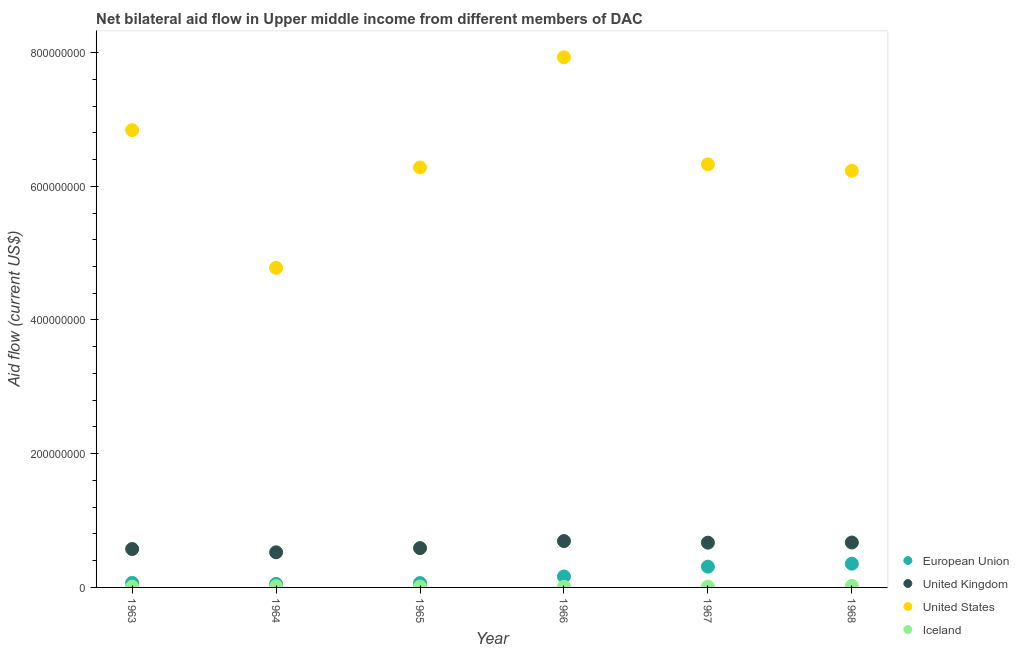How many different coloured dotlines are there?
Make the answer very short. 4. What is the amount of aid given by us in 1968?
Offer a terse response. 6.23e+08. Across all years, what is the maximum amount of aid given by eu?
Offer a very short reply. 3.55e+07. Across all years, what is the minimum amount of aid given by eu?
Ensure brevity in your answer.  5.22e+06. In which year was the amount of aid given by eu maximum?
Keep it short and to the point. 1968. In which year was the amount of aid given by eu minimum?
Keep it short and to the point. 1964. What is the total amount of aid given by iceland in the graph?
Keep it short and to the point. 8.60e+06. What is the difference between the amount of aid given by iceland in 1966 and that in 1967?
Give a very brief answer. -1.90e+05. What is the difference between the amount of aid given by eu in 1963 and the amount of aid given by uk in 1967?
Ensure brevity in your answer.  -6.02e+07. What is the average amount of aid given by eu per year?
Provide a short and direct response. 1.69e+07. In the year 1964, what is the difference between the amount of aid given by eu and amount of aid given by uk?
Keep it short and to the point. -4.73e+07. In how many years, is the amount of aid given by us greater than 760000000 US$?
Your response must be concise. 1. What is the ratio of the amount of aid given by eu in 1964 to that in 1967?
Give a very brief answer. 0.17. Is the difference between the amount of aid given by us in 1963 and 1965 greater than the difference between the amount of aid given by uk in 1963 and 1965?
Provide a short and direct response. Yes. What is the difference between the highest and the second highest amount of aid given by iceland?
Give a very brief answer. 5.10e+05. What is the difference between the highest and the lowest amount of aid given by eu?
Keep it short and to the point. 3.03e+07. Is the amount of aid given by iceland strictly greater than the amount of aid given by eu over the years?
Offer a very short reply. No. Is the amount of aid given by us strictly less than the amount of aid given by eu over the years?
Give a very brief answer. No. How many dotlines are there?
Your response must be concise. 4. How many years are there in the graph?
Offer a very short reply. 6. What is the difference between two consecutive major ticks on the Y-axis?
Provide a short and direct response. 2.00e+08. Are the values on the major ticks of Y-axis written in scientific E-notation?
Your answer should be very brief. No. Does the graph contain any zero values?
Make the answer very short. No. Where does the legend appear in the graph?
Ensure brevity in your answer.  Bottom right. How are the legend labels stacked?
Your answer should be very brief. Vertical. What is the title of the graph?
Your response must be concise. Net bilateral aid flow in Upper middle income from different members of DAC. What is the label or title of the X-axis?
Your response must be concise. Year. What is the label or title of the Y-axis?
Offer a very short reply. Aid flow (current US$). What is the Aid flow (current US$) in European Union in 1963?
Ensure brevity in your answer.  6.73e+06. What is the Aid flow (current US$) of United Kingdom in 1963?
Your answer should be compact. 5.74e+07. What is the Aid flow (current US$) of United States in 1963?
Your response must be concise. 6.84e+08. What is the Aid flow (current US$) in Iceland in 1963?
Provide a succinct answer. 1.18e+06. What is the Aid flow (current US$) in European Union in 1964?
Give a very brief answer. 5.22e+06. What is the Aid flow (current US$) of United Kingdom in 1964?
Your answer should be compact. 5.25e+07. What is the Aid flow (current US$) of United States in 1964?
Ensure brevity in your answer.  4.78e+08. What is the Aid flow (current US$) of Iceland in 1964?
Ensure brevity in your answer.  1.74e+06. What is the Aid flow (current US$) in European Union in 1965?
Make the answer very short. 6.46e+06. What is the Aid flow (current US$) in United Kingdom in 1965?
Offer a terse response. 5.88e+07. What is the Aid flow (current US$) in United States in 1965?
Ensure brevity in your answer.  6.28e+08. What is the Aid flow (current US$) in Iceland in 1965?
Provide a succinct answer. 1.26e+06. What is the Aid flow (current US$) of European Union in 1966?
Give a very brief answer. 1.64e+07. What is the Aid flow (current US$) in United Kingdom in 1966?
Provide a succinct answer. 6.93e+07. What is the Aid flow (current US$) in United States in 1966?
Provide a succinct answer. 7.93e+08. What is the Aid flow (current US$) in Iceland in 1966?
Offer a very short reply. 9.90e+05. What is the Aid flow (current US$) of European Union in 1967?
Your answer should be compact. 3.11e+07. What is the Aid flow (current US$) of United Kingdom in 1967?
Ensure brevity in your answer.  6.69e+07. What is the Aid flow (current US$) of United States in 1967?
Give a very brief answer. 6.33e+08. What is the Aid flow (current US$) of Iceland in 1967?
Your response must be concise. 1.18e+06. What is the Aid flow (current US$) of European Union in 1968?
Your response must be concise. 3.55e+07. What is the Aid flow (current US$) of United Kingdom in 1968?
Keep it short and to the point. 6.72e+07. What is the Aid flow (current US$) in United States in 1968?
Your answer should be compact. 6.23e+08. What is the Aid flow (current US$) of Iceland in 1968?
Offer a terse response. 2.25e+06. Across all years, what is the maximum Aid flow (current US$) of European Union?
Your answer should be very brief. 3.55e+07. Across all years, what is the maximum Aid flow (current US$) of United Kingdom?
Offer a very short reply. 6.93e+07. Across all years, what is the maximum Aid flow (current US$) in United States?
Make the answer very short. 7.93e+08. Across all years, what is the maximum Aid flow (current US$) of Iceland?
Make the answer very short. 2.25e+06. Across all years, what is the minimum Aid flow (current US$) in European Union?
Your answer should be compact. 5.22e+06. Across all years, what is the minimum Aid flow (current US$) of United Kingdom?
Provide a short and direct response. 5.25e+07. Across all years, what is the minimum Aid flow (current US$) in United States?
Provide a succinct answer. 4.78e+08. Across all years, what is the minimum Aid flow (current US$) of Iceland?
Make the answer very short. 9.90e+05. What is the total Aid flow (current US$) in European Union in the graph?
Your answer should be compact. 1.01e+08. What is the total Aid flow (current US$) in United Kingdom in the graph?
Provide a short and direct response. 3.72e+08. What is the total Aid flow (current US$) of United States in the graph?
Provide a succinct answer. 3.84e+09. What is the total Aid flow (current US$) of Iceland in the graph?
Your answer should be very brief. 8.60e+06. What is the difference between the Aid flow (current US$) in European Union in 1963 and that in 1964?
Give a very brief answer. 1.51e+06. What is the difference between the Aid flow (current US$) of United Kingdom in 1963 and that in 1964?
Make the answer very short. 4.92e+06. What is the difference between the Aid flow (current US$) in United States in 1963 and that in 1964?
Keep it short and to the point. 2.06e+08. What is the difference between the Aid flow (current US$) of Iceland in 1963 and that in 1964?
Your response must be concise. -5.60e+05. What is the difference between the Aid flow (current US$) in European Union in 1963 and that in 1965?
Provide a succinct answer. 2.70e+05. What is the difference between the Aid flow (current US$) of United Kingdom in 1963 and that in 1965?
Keep it short and to the point. -1.36e+06. What is the difference between the Aid flow (current US$) of United States in 1963 and that in 1965?
Your answer should be very brief. 5.59e+07. What is the difference between the Aid flow (current US$) of European Union in 1963 and that in 1966?
Your answer should be compact. -9.64e+06. What is the difference between the Aid flow (current US$) in United Kingdom in 1963 and that in 1966?
Keep it short and to the point. -1.19e+07. What is the difference between the Aid flow (current US$) of United States in 1963 and that in 1966?
Provide a short and direct response. -1.09e+08. What is the difference between the Aid flow (current US$) in European Union in 1963 and that in 1967?
Offer a terse response. -2.44e+07. What is the difference between the Aid flow (current US$) of United Kingdom in 1963 and that in 1967?
Keep it short and to the point. -9.49e+06. What is the difference between the Aid flow (current US$) in United States in 1963 and that in 1967?
Offer a terse response. 5.12e+07. What is the difference between the Aid flow (current US$) in European Union in 1963 and that in 1968?
Provide a short and direct response. -2.88e+07. What is the difference between the Aid flow (current US$) in United Kingdom in 1963 and that in 1968?
Offer a terse response. -9.73e+06. What is the difference between the Aid flow (current US$) in United States in 1963 and that in 1968?
Your answer should be very brief. 6.08e+07. What is the difference between the Aid flow (current US$) of Iceland in 1963 and that in 1968?
Your answer should be compact. -1.07e+06. What is the difference between the Aid flow (current US$) of European Union in 1964 and that in 1965?
Offer a terse response. -1.24e+06. What is the difference between the Aid flow (current US$) of United Kingdom in 1964 and that in 1965?
Keep it short and to the point. -6.28e+06. What is the difference between the Aid flow (current US$) in United States in 1964 and that in 1965?
Provide a succinct answer. -1.50e+08. What is the difference between the Aid flow (current US$) of European Union in 1964 and that in 1966?
Keep it short and to the point. -1.12e+07. What is the difference between the Aid flow (current US$) in United Kingdom in 1964 and that in 1966?
Offer a very short reply. -1.68e+07. What is the difference between the Aid flow (current US$) of United States in 1964 and that in 1966?
Your answer should be very brief. -3.15e+08. What is the difference between the Aid flow (current US$) of Iceland in 1964 and that in 1966?
Offer a terse response. 7.50e+05. What is the difference between the Aid flow (current US$) of European Union in 1964 and that in 1967?
Your response must be concise. -2.59e+07. What is the difference between the Aid flow (current US$) of United Kingdom in 1964 and that in 1967?
Keep it short and to the point. -1.44e+07. What is the difference between the Aid flow (current US$) in United States in 1964 and that in 1967?
Give a very brief answer. -1.55e+08. What is the difference between the Aid flow (current US$) of Iceland in 1964 and that in 1967?
Offer a terse response. 5.60e+05. What is the difference between the Aid flow (current US$) of European Union in 1964 and that in 1968?
Your response must be concise. -3.03e+07. What is the difference between the Aid flow (current US$) of United Kingdom in 1964 and that in 1968?
Your answer should be compact. -1.46e+07. What is the difference between the Aid flow (current US$) of United States in 1964 and that in 1968?
Provide a short and direct response. -1.45e+08. What is the difference between the Aid flow (current US$) in Iceland in 1964 and that in 1968?
Make the answer very short. -5.10e+05. What is the difference between the Aid flow (current US$) of European Union in 1965 and that in 1966?
Offer a terse response. -9.91e+06. What is the difference between the Aid flow (current US$) of United Kingdom in 1965 and that in 1966?
Your answer should be compact. -1.05e+07. What is the difference between the Aid flow (current US$) in United States in 1965 and that in 1966?
Make the answer very short. -1.65e+08. What is the difference between the Aid flow (current US$) in European Union in 1965 and that in 1967?
Give a very brief answer. -2.46e+07. What is the difference between the Aid flow (current US$) of United Kingdom in 1965 and that in 1967?
Your response must be concise. -8.13e+06. What is the difference between the Aid flow (current US$) of United States in 1965 and that in 1967?
Keep it short and to the point. -4.62e+06. What is the difference between the Aid flow (current US$) in Iceland in 1965 and that in 1967?
Make the answer very short. 8.00e+04. What is the difference between the Aid flow (current US$) in European Union in 1965 and that in 1968?
Your response must be concise. -2.90e+07. What is the difference between the Aid flow (current US$) of United Kingdom in 1965 and that in 1968?
Your answer should be very brief. -8.37e+06. What is the difference between the Aid flow (current US$) of United States in 1965 and that in 1968?
Make the answer very short. 4.89e+06. What is the difference between the Aid flow (current US$) in Iceland in 1965 and that in 1968?
Offer a very short reply. -9.90e+05. What is the difference between the Aid flow (current US$) of European Union in 1966 and that in 1967?
Give a very brief answer. -1.47e+07. What is the difference between the Aid flow (current US$) of United Kingdom in 1966 and that in 1967?
Provide a short and direct response. 2.40e+06. What is the difference between the Aid flow (current US$) in United States in 1966 and that in 1967?
Give a very brief answer. 1.60e+08. What is the difference between the Aid flow (current US$) of European Union in 1966 and that in 1968?
Offer a terse response. -1.91e+07. What is the difference between the Aid flow (current US$) of United Kingdom in 1966 and that in 1968?
Provide a succinct answer. 2.16e+06. What is the difference between the Aid flow (current US$) of United States in 1966 and that in 1968?
Your response must be concise. 1.70e+08. What is the difference between the Aid flow (current US$) of Iceland in 1966 and that in 1968?
Your answer should be compact. -1.26e+06. What is the difference between the Aid flow (current US$) in European Union in 1967 and that in 1968?
Keep it short and to the point. -4.41e+06. What is the difference between the Aid flow (current US$) in United Kingdom in 1967 and that in 1968?
Ensure brevity in your answer.  -2.40e+05. What is the difference between the Aid flow (current US$) in United States in 1967 and that in 1968?
Offer a very short reply. 9.51e+06. What is the difference between the Aid flow (current US$) in Iceland in 1967 and that in 1968?
Offer a very short reply. -1.07e+06. What is the difference between the Aid flow (current US$) of European Union in 1963 and the Aid flow (current US$) of United Kingdom in 1964?
Your response must be concise. -4.58e+07. What is the difference between the Aid flow (current US$) in European Union in 1963 and the Aid flow (current US$) in United States in 1964?
Offer a terse response. -4.71e+08. What is the difference between the Aid flow (current US$) in European Union in 1963 and the Aid flow (current US$) in Iceland in 1964?
Offer a terse response. 4.99e+06. What is the difference between the Aid flow (current US$) of United Kingdom in 1963 and the Aid flow (current US$) of United States in 1964?
Provide a succinct answer. -4.21e+08. What is the difference between the Aid flow (current US$) of United Kingdom in 1963 and the Aid flow (current US$) of Iceland in 1964?
Give a very brief answer. 5.57e+07. What is the difference between the Aid flow (current US$) of United States in 1963 and the Aid flow (current US$) of Iceland in 1964?
Provide a succinct answer. 6.82e+08. What is the difference between the Aid flow (current US$) in European Union in 1963 and the Aid flow (current US$) in United Kingdom in 1965?
Provide a succinct answer. -5.21e+07. What is the difference between the Aid flow (current US$) of European Union in 1963 and the Aid flow (current US$) of United States in 1965?
Your response must be concise. -6.21e+08. What is the difference between the Aid flow (current US$) of European Union in 1963 and the Aid flow (current US$) of Iceland in 1965?
Offer a terse response. 5.47e+06. What is the difference between the Aid flow (current US$) in United Kingdom in 1963 and the Aid flow (current US$) in United States in 1965?
Make the answer very short. -5.71e+08. What is the difference between the Aid flow (current US$) in United Kingdom in 1963 and the Aid flow (current US$) in Iceland in 1965?
Offer a very short reply. 5.62e+07. What is the difference between the Aid flow (current US$) in United States in 1963 and the Aid flow (current US$) in Iceland in 1965?
Your answer should be very brief. 6.83e+08. What is the difference between the Aid flow (current US$) in European Union in 1963 and the Aid flow (current US$) in United Kingdom in 1966?
Make the answer very short. -6.26e+07. What is the difference between the Aid flow (current US$) in European Union in 1963 and the Aid flow (current US$) in United States in 1966?
Provide a short and direct response. -7.86e+08. What is the difference between the Aid flow (current US$) of European Union in 1963 and the Aid flow (current US$) of Iceland in 1966?
Provide a succinct answer. 5.74e+06. What is the difference between the Aid flow (current US$) of United Kingdom in 1963 and the Aid flow (current US$) of United States in 1966?
Give a very brief answer. -7.35e+08. What is the difference between the Aid flow (current US$) of United Kingdom in 1963 and the Aid flow (current US$) of Iceland in 1966?
Keep it short and to the point. 5.65e+07. What is the difference between the Aid flow (current US$) of United States in 1963 and the Aid flow (current US$) of Iceland in 1966?
Keep it short and to the point. 6.83e+08. What is the difference between the Aid flow (current US$) of European Union in 1963 and the Aid flow (current US$) of United Kingdom in 1967?
Your response must be concise. -6.02e+07. What is the difference between the Aid flow (current US$) in European Union in 1963 and the Aid flow (current US$) in United States in 1967?
Offer a terse response. -6.26e+08. What is the difference between the Aid flow (current US$) in European Union in 1963 and the Aid flow (current US$) in Iceland in 1967?
Offer a terse response. 5.55e+06. What is the difference between the Aid flow (current US$) in United Kingdom in 1963 and the Aid flow (current US$) in United States in 1967?
Offer a terse response. -5.75e+08. What is the difference between the Aid flow (current US$) of United Kingdom in 1963 and the Aid flow (current US$) of Iceland in 1967?
Make the answer very short. 5.63e+07. What is the difference between the Aid flow (current US$) of United States in 1963 and the Aid flow (current US$) of Iceland in 1967?
Keep it short and to the point. 6.83e+08. What is the difference between the Aid flow (current US$) of European Union in 1963 and the Aid flow (current US$) of United Kingdom in 1968?
Your answer should be very brief. -6.04e+07. What is the difference between the Aid flow (current US$) of European Union in 1963 and the Aid flow (current US$) of United States in 1968?
Offer a terse response. -6.17e+08. What is the difference between the Aid flow (current US$) in European Union in 1963 and the Aid flow (current US$) in Iceland in 1968?
Ensure brevity in your answer.  4.48e+06. What is the difference between the Aid flow (current US$) in United Kingdom in 1963 and the Aid flow (current US$) in United States in 1968?
Make the answer very short. -5.66e+08. What is the difference between the Aid flow (current US$) in United Kingdom in 1963 and the Aid flow (current US$) in Iceland in 1968?
Give a very brief answer. 5.52e+07. What is the difference between the Aid flow (current US$) in United States in 1963 and the Aid flow (current US$) in Iceland in 1968?
Your answer should be very brief. 6.82e+08. What is the difference between the Aid flow (current US$) in European Union in 1964 and the Aid flow (current US$) in United Kingdom in 1965?
Your response must be concise. -5.36e+07. What is the difference between the Aid flow (current US$) of European Union in 1964 and the Aid flow (current US$) of United States in 1965?
Your answer should be compact. -6.23e+08. What is the difference between the Aid flow (current US$) in European Union in 1964 and the Aid flow (current US$) in Iceland in 1965?
Your answer should be compact. 3.96e+06. What is the difference between the Aid flow (current US$) of United Kingdom in 1964 and the Aid flow (current US$) of United States in 1965?
Provide a succinct answer. -5.76e+08. What is the difference between the Aid flow (current US$) in United Kingdom in 1964 and the Aid flow (current US$) in Iceland in 1965?
Your response must be concise. 5.13e+07. What is the difference between the Aid flow (current US$) in United States in 1964 and the Aid flow (current US$) in Iceland in 1965?
Give a very brief answer. 4.77e+08. What is the difference between the Aid flow (current US$) of European Union in 1964 and the Aid flow (current US$) of United Kingdom in 1966?
Your response must be concise. -6.41e+07. What is the difference between the Aid flow (current US$) in European Union in 1964 and the Aid flow (current US$) in United States in 1966?
Offer a very short reply. -7.88e+08. What is the difference between the Aid flow (current US$) of European Union in 1964 and the Aid flow (current US$) of Iceland in 1966?
Provide a short and direct response. 4.23e+06. What is the difference between the Aid flow (current US$) of United Kingdom in 1964 and the Aid flow (current US$) of United States in 1966?
Make the answer very short. -7.40e+08. What is the difference between the Aid flow (current US$) of United Kingdom in 1964 and the Aid flow (current US$) of Iceland in 1966?
Make the answer very short. 5.15e+07. What is the difference between the Aid flow (current US$) of United States in 1964 and the Aid flow (current US$) of Iceland in 1966?
Provide a short and direct response. 4.77e+08. What is the difference between the Aid flow (current US$) of European Union in 1964 and the Aid flow (current US$) of United Kingdom in 1967?
Provide a short and direct response. -6.17e+07. What is the difference between the Aid flow (current US$) of European Union in 1964 and the Aid flow (current US$) of United States in 1967?
Offer a terse response. -6.28e+08. What is the difference between the Aid flow (current US$) in European Union in 1964 and the Aid flow (current US$) in Iceland in 1967?
Your response must be concise. 4.04e+06. What is the difference between the Aid flow (current US$) of United Kingdom in 1964 and the Aid flow (current US$) of United States in 1967?
Make the answer very short. -5.80e+08. What is the difference between the Aid flow (current US$) in United Kingdom in 1964 and the Aid flow (current US$) in Iceland in 1967?
Provide a short and direct response. 5.14e+07. What is the difference between the Aid flow (current US$) in United States in 1964 and the Aid flow (current US$) in Iceland in 1967?
Your response must be concise. 4.77e+08. What is the difference between the Aid flow (current US$) of European Union in 1964 and the Aid flow (current US$) of United Kingdom in 1968?
Offer a very short reply. -6.20e+07. What is the difference between the Aid flow (current US$) in European Union in 1964 and the Aid flow (current US$) in United States in 1968?
Offer a very short reply. -6.18e+08. What is the difference between the Aid flow (current US$) of European Union in 1964 and the Aid flow (current US$) of Iceland in 1968?
Provide a short and direct response. 2.97e+06. What is the difference between the Aid flow (current US$) in United Kingdom in 1964 and the Aid flow (current US$) in United States in 1968?
Provide a short and direct response. -5.71e+08. What is the difference between the Aid flow (current US$) of United Kingdom in 1964 and the Aid flow (current US$) of Iceland in 1968?
Offer a very short reply. 5.03e+07. What is the difference between the Aid flow (current US$) in United States in 1964 and the Aid flow (current US$) in Iceland in 1968?
Your answer should be very brief. 4.76e+08. What is the difference between the Aid flow (current US$) in European Union in 1965 and the Aid flow (current US$) in United Kingdom in 1966?
Give a very brief answer. -6.29e+07. What is the difference between the Aid flow (current US$) in European Union in 1965 and the Aid flow (current US$) in United States in 1966?
Make the answer very short. -7.86e+08. What is the difference between the Aid flow (current US$) in European Union in 1965 and the Aid flow (current US$) in Iceland in 1966?
Give a very brief answer. 5.47e+06. What is the difference between the Aid flow (current US$) of United Kingdom in 1965 and the Aid flow (current US$) of United States in 1966?
Provide a succinct answer. -7.34e+08. What is the difference between the Aid flow (current US$) in United Kingdom in 1965 and the Aid flow (current US$) in Iceland in 1966?
Your answer should be compact. 5.78e+07. What is the difference between the Aid flow (current US$) of United States in 1965 and the Aid flow (current US$) of Iceland in 1966?
Provide a succinct answer. 6.27e+08. What is the difference between the Aid flow (current US$) in European Union in 1965 and the Aid flow (current US$) in United Kingdom in 1967?
Your answer should be very brief. -6.05e+07. What is the difference between the Aid flow (current US$) of European Union in 1965 and the Aid flow (current US$) of United States in 1967?
Provide a short and direct response. -6.26e+08. What is the difference between the Aid flow (current US$) of European Union in 1965 and the Aid flow (current US$) of Iceland in 1967?
Make the answer very short. 5.28e+06. What is the difference between the Aid flow (current US$) of United Kingdom in 1965 and the Aid flow (current US$) of United States in 1967?
Your answer should be very brief. -5.74e+08. What is the difference between the Aid flow (current US$) in United Kingdom in 1965 and the Aid flow (current US$) in Iceland in 1967?
Ensure brevity in your answer.  5.76e+07. What is the difference between the Aid flow (current US$) of United States in 1965 and the Aid flow (current US$) of Iceland in 1967?
Ensure brevity in your answer.  6.27e+08. What is the difference between the Aid flow (current US$) in European Union in 1965 and the Aid flow (current US$) in United Kingdom in 1968?
Ensure brevity in your answer.  -6.07e+07. What is the difference between the Aid flow (current US$) in European Union in 1965 and the Aid flow (current US$) in United States in 1968?
Provide a short and direct response. -6.17e+08. What is the difference between the Aid flow (current US$) in European Union in 1965 and the Aid flow (current US$) in Iceland in 1968?
Your answer should be very brief. 4.21e+06. What is the difference between the Aid flow (current US$) in United Kingdom in 1965 and the Aid flow (current US$) in United States in 1968?
Provide a succinct answer. -5.64e+08. What is the difference between the Aid flow (current US$) of United Kingdom in 1965 and the Aid flow (current US$) of Iceland in 1968?
Provide a succinct answer. 5.66e+07. What is the difference between the Aid flow (current US$) in United States in 1965 and the Aid flow (current US$) in Iceland in 1968?
Your response must be concise. 6.26e+08. What is the difference between the Aid flow (current US$) in European Union in 1966 and the Aid flow (current US$) in United Kingdom in 1967?
Offer a very short reply. -5.06e+07. What is the difference between the Aid flow (current US$) of European Union in 1966 and the Aid flow (current US$) of United States in 1967?
Your response must be concise. -6.16e+08. What is the difference between the Aid flow (current US$) of European Union in 1966 and the Aid flow (current US$) of Iceland in 1967?
Provide a short and direct response. 1.52e+07. What is the difference between the Aid flow (current US$) in United Kingdom in 1966 and the Aid flow (current US$) in United States in 1967?
Provide a short and direct response. -5.63e+08. What is the difference between the Aid flow (current US$) in United Kingdom in 1966 and the Aid flow (current US$) in Iceland in 1967?
Make the answer very short. 6.82e+07. What is the difference between the Aid flow (current US$) in United States in 1966 and the Aid flow (current US$) in Iceland in 1967?
Make the answer very short. 7.92e+08. What is the difference between the Aid flow (current US$) in European Union in 1966 and the Aid flow (current US$) in United Kingdom in 1968?
Provide a short and direct response. -5.08e+07. What is the difference between the Aid flow (current US$) of European Union in 1966 and the Aid flow (current US$) of United States in 1968?
Your response must be concise. -6.07e+08. What is the difference between the Aid flow (current US$) of European Union in 1966 and the Aid flow (current US$) of Iceland in 1968?
Give a very brief answer. 1.41e+07. What is the difference between the Aid flow (current US$) of United Kingdom in 1966 and the Aid flow (current US$) of United States in 1968?
Your answer should be compact. -5.54e+08. What is the difference between the Aid flow (current US$) of United Kingdom in 1966 and the Aid flow (current US$) of Iceland in 1968?
Give a very brief answer. 6.71e+07. What is the difference between the Aid flow (current US$) of United States in 1966 and the Aid flow (current US$) of Iceland in 1968?
Keep it short and to the point. 7.91e+08. What is the difference between the Aid flow (current US$) in European Union in 1967 and the Aid flow (current US$) in United Kingdom in 1968?
Your answer should be very brief. -3.61e+07. What is the difference between the Aid flow (current US$) in European Union in 1967 and the Aid flow (current US$) in United States in 1968?
Provide a succinct answer. -5.92e+08. What is the difference between the Aid flow (current US$) of European Union in 1967 and the Aid flow (current US$) of Iceland in 1968?
Your answer should be compact. 2.88e+07. What is the difference between the Aid flow (current US$) of United Kingdom in 1967 and the Aid flow (current US$) of United States in 1968?
Keep it short and to the point. -5.56e+08. What is the difference between the Aid flow (current US$) in United Kingdom in 1967 and the Aid flow (current US$) in Iceland in 1968?
Give a very brief answer. 6.47e+07. What is the difference between the Aid flow (current US$) of United States in 1967 and the Aid flow (current US$) of Iceland in 1968?
Your answer should be very brief. 6.30e+08. What is the average Aid flow (current US$) in European Union per year?
Ensure brevity in your answer.  1.69e+07. What is the average Aid flow (current US$) of United Kingdom per year?
Provide a succinct answer. 6.20e+07. What is the average Aid flow (current US$) of United States per year?
Give a very brief answer. 6.40e+08. What is the average Aid flow (current US$) in Iceland per year?
Offer a very short reply. 1.43e+06. In the year 1963, what is the difference between the Aid flow (current US$) of European Union and Aid flow (current US$) of United Kingdom?
Offer a terse response. -5.07e+07. In the year 1963, what is the difference between the Aid flow (current US$) in European Union and Aid flow (current US$) in United States?
Provide a succinct answer. -6.77e+08. In the year 1963, what is the difference between the Aid flow (current US$) in European Union and Aid flow (current US$) in Iceland?
Your response must be concise. 5.55e+06. In the year 1963, what is the difference between the Aid flow (current US$) of United Kingdom and Aid flow (current US$) of United States?
Provide a succinct answer. -6.27e+08. In the year 1963, what is the difference between the Aid flow (current US$) of United Kingdom and Aid flow (current US$) of Iceland?
Offer a terse response. 5.63e+07. In the year 1963, what is the difference between the Aid flow (current US$) in United States and Aid flow (current US$) in Iceland?
Ensure brevity in your answer.  6.83e+08. In the year 1964, what is the difference between the Aid flow (current US$) in European Union and Aid flow (current US$) in United Kingdom?
Keep it short and to the point. -4.73e+07. In the year 1964, what is the difference between the Aid flow (current US$) in European Union and Aid flow (current US$) in United States?
Provide a short and direct response. -4.73e+08. In the year 1964, what is the difference between the Aid flow (current US$) in European Union and Aid flow (current US$) in Iceland?
Your answer should be very brief. 3.48e+06. In the year 1964, what is the difference between the Aid flow (current US$) of United Kingdom and Aid flow (current US$) of United States?
Offer a very short reply. -4.25e+08. In the year 1964, what is the difference between the Aid flow (current US$) in United Kingdom and Aid flow (current US$) in Iceland?
Your response must be concise. 5.08e+07. In the year 1964, what is the difference between the Aid flow (current US$) in United States and Aid flow (current US$) in Iceland?
Offer a terse response. 4.76e+08. In the year 1965, what is the difference between the Aid flow (current US$) of European Union and Aid flow (current US$) of United Kingdom?
Provide a succinct answer. -5.24e+07. In the year 1965, what is the difference between the Aid flow (current US$) in European Union and Aid flow (current US$) in United States?
Provide a short and direct response. -6.22e+08. In the year 1965, what is the difference between the Aid flow (current US$) of European Union and Aid flow (current US$) of Iceland?
Provide a succinct answer. 5.20e+06. In the year 1965, what is the difference between the Aid flow (current US$) of United Kingdom and Aid flow (current US$) of United States?
Give a very brief answer. -5.69e+08. In the year 1965, what is the difference between the Aid flow (current US$) in United Kingdom and Aid flow (current US$) in Iceland?
Your answer should be very brief. 5.76e+07. In the year 1965, what is the difference between the Aid flow (current US$) in United States and Aid flow (current US$) in Iceland?
Make the answer very short. 6.27e+08. In the year 1966, what is the difference between the Aid flow (current US$) of European Union and Aid flow (current US$) of United Kingdom?
Offer a very short reply. -5.30e+07. In the year 1966, what is the difference between the Aid flow (current US$) in European Union and Aid flow (current US$) in United States?
Provide a succinct answer. -7.77e+08. In the year 1966, what is the difference between the Aid flow (current US$) in European Union and Aid flow (current US$) in Iceland?
Ensure brevity in your answer.  1.54e+07. In the year 1966, what is the difference between the Aid flow (current US$) of United Kingdom and Aid flow (current US$) of United States?
Provide a succinct answer. -7.24e+08. In the year 1966, what is the difference between the Aid flow (current US$) in United Kingdom and Aid flow (current US$) in Iceland?
Offer a very short reply. 6.84e+07. In the year 1966, what is the difference between the Aid flow (current US$) in United States and Aid flow (current US$) in Iceland?
Provide a short and direct response. 7.92e+08. In the year 1967, what is the difference between the Aid flow (current US$) in European Union and Aid flow (current US$) in United Kingdom?
Ensure brevity in your answer.  -3.58e+07. In the year 1967, what is the difference between the Aid flow (current US$) in European Union and Aid flow (current US$) in United States?
Ensure brevity in your answer.  -6.02e+08. In the year 1967, what is the difference between the Aid flow (current US$) of European Union and Aid flow (current US$) of Iceland?
Provide a succinct answer. 2.99e+07. In the year 1967, what is the difference between the Aid flow (current US$) of United Kingdom and Aid flow (current US$) of United States?
Provide a short and direct response. -5.66e+08. In the year 1967, what is the difference between the Aid flow (current US$) of United Kingdom and Aid flow (current US$) of Iceland?
Your response must be concise. 6.58e+07. In the year 1967, what is the difference between the Aid flow (current US$) of United States and Aid flow (current US$) of Iceland?
Your response must be concise. 6.32e+08. In the year 1968, what is the difference between the Aid flow (current US$) of European Union and Aid flow (current US$) of United Kingdom?
Your response must be concise. -3.17e+07. In the year 1968, what is the difference between the Aid flow (current US$) in European Union and Aid flow (current US$) in United States?
Make the answer very short. -5.88e+08. In the year 1968, what is the difference between the Aid flow (current US$) in European Union and Aid flow (current US$) in Iceland?
Your answer should be very brief. 3.32e+07. In the year 1968, what is the difference between the Aid flow (current US$) in United Kingdom and Aid flow (current US$) in United States?
Your response must be concise. -5.56e+08. In the year 1968, what is the difference between the Aid flow (current US$) of United Kingdom and Aid flow (current US$) of Iceland?
Keep it short and to the point. 6.49e+07. In the year 1968, what is the difference between the Aid flow (current US$) in United States and Aid flow (current US$) in Iceland?
Your answer should be very brief. 6.21e+08. What is the ratio of the Aid flow (current US$) of European Union in 1963 to that in 1964?
Make the answer very short. 1.29. What is the ratio of the Aid flow (current US$) in United Kingdom in 1963 to that in 1964?
Make the answer very short. 1.09. What is the ratio of the Aid flow (current US$) of United States in 1963 to that in 1964?
Your answer should be compact. 1.43. What is the ratio of the Aid flow (current US$) of Iceland in 1963 to that in 1964?
Your response must be concise. 0.68. What is the ratio of the Aid flow (current US$) of European Union in 1963 to that in 1965?
Provide a short and direct response. 1.04. What is the ratio of the Aid flow (current US$) in United Kingdom in 1963 to that in 1965?
Your response must be concise. 0.98. What is the ratio of the Aid flow (current US$) of United States in 1963 to that in 1965?
Give a very brief answer. 1.09. What is the ratio of the Aid flow (current US$) of Iceland in 1963 to that in 1965?
Provide a short and direct response. 0.94. What is the ratio of the Aid flow (current US$) in European Union in 1963 to that in 1966?
Give a very brief answer. 0.41. What is the ratio of the Aid flow (current US$) in United Kingdom in 1963 to that in 1966?
Give a very brief answer. 0.83. What is the ratio of the Aid flow (current US$) of United States in 1963 to that in 1966?
Offer a terse response. 0.86. What is the ratio of the Aid flow (current US$) of Iceland in 1963 to that in 1966?
Your answer should be compact. 1.19. What is the ratio of the Aid flow (current US$) in European Union in 1963 to that in 1967?
Make the answer very short. 0.22. What is the ratio of the Aid flow (current US$) of United Kingdom in 1963 to that in 1967?
Provide a short and direct response. 0.86. What is the ratio of the Aid flow (current US$) in United States in 1963 to that in 1967?
Provide a succinct answer. 1.08. What is the ratio of the Aid flow (current US$) of Iceland in 1963 to that in 1967?
Give a very brief answer. 1. What is the ratio of the Aid flow (current US$) of European Union in 1963 to that in 1968?
Keep it short and to the point. 0.19. What is the ratio of the Aid flow (current US$) of United Kingdom in 1963 to that in 1968?
Provide a short and direct response. 0.86. What is the ratio of the Aid flow (current US$) of United States in 1963 to that in 1968?
Offer a terse response. 1.1. What is the ratio of the Aid flow (current US$) in Iceland in 1963 to that in 1968?
Make the answer very short. 0.52. What is the ratio of the Aid flow (current US$) in European Union in 1964 to that in 1965?
Your response must be concise. 0.81. What is the ratio of the Aid flow (current US$) in United Kingdom in 1964 to that in 1965?
Make the answer very short. 0.89. What is the ratio of the Aid flow (current US$) of United States in 1964 to that in 1965?
Provide a short and direct response. 0.76. What is the ratio of the Aid flow (current US$) of Iceland in 1964 to that in 1965?
Your answer should be very brief. 1.38. What is the ratio of the Aid flow (current US$) of European Union in 1964 to that in 1966?
Provide a short and direct response. 0.32. What is the ratio of the Aid flow (current US$) of United Kingdom in 1964 to that in 1966?
Your response must be concise. 0.76. What is the ratio of the Aid flow (current US$) in United States in 1964 to that in 1966?
Provide a succinct answer. 0.6. What is the ratio of the Aid flow (current US$) in Iceland in 1964 to that in 1966?
Offer a terse response. 1.76. What is the ratio of the Aid flow (current US$) in European Union in 1964 to that in 1967?
Ensure brevity in your answer.  0.17. What is the ratio of the Aid flow (current US$) of United Kingdom in 1964 to that in 1967?
Your answer should be compact. 0.78. What is the ratio of the Aid flow (current US$) of United States in 1964 to that in 1967?
Provide a succinct answer. 0.76. What is the ratio of the Aid flow (current US$) in Iceland in 1964 to that in 1967?
Ensure brevity in your answer.  1.47. What is the ratio of the Aid flow (current US$) in European Union in 1964 to that in 1968?
Your response must be concise. 0.15. What is the ratio of the Aid flow (current US$) in United Kingdom in 1964 to that in 1968?
Offer a terse response. 0.78. What is the ratio of the Aid flow (current US$) in United States in 1964 to that in 1968?
Your response must be concise. 0.77. What is the ratio of the Aid flow (current US$) in Iceland in 1964 to that in 1968?
Give a very brief answer. 0.77. What is the ratio of the Aid flow (current US$) in European Union in 1965 to that in 1966?
Your response must be concise. 0.39. What is the ratio of the Aid flow (current US$) in United Kingdom in 1965 to that in 1966?
Make the answer very short. 0.85. What is the ratio of the Aid flow (current US$) in United States in 1965 to that in 1966?
Provide a succinct answer. 0.79. What is the ratio of the Aid flow (current US$) of Iceland in 1965 to that in 1966?
Ensure brevity in your answer.  1.27. What is the ratio of the Aid flow (current US$) of European Union in 1965 to that in 1967?
Your response must be concise. 0.21. What is the ratio of the Aid flow (current US$) in United Kingdom in 1965 to that in 1967?
Your answer should be compact. 0.88. What is the ratio of the Aid flow (current US$) of Iceland in 1965 to that in 1967?
Ensure brevity in your answer.  1.07. What is the ratio of the Aid flow (current US$) of European Union in 1965 to that in 1968?
Your answer should be very brief. 0.18. What is the ratio of the Aid flow (current US$) in United Kingdom in 1965 to that in 1968?
Provide a succinct answer. 0.88. What is the ratio of the Aid flow (current US$) of United States in 1965 to that in 1968?
Give a very brief answer. 1.01. What is the ratio of the Aid flow (current US$) in Iceland in 1965 to that in 1968?
Provide a succinct answer. 0.56. What is the ratio of the Aid flow (current US$) of European Union in 1966 to that in 1967?
Offer a very short reply. 0.53. What is the ratio of the Aid flow (current US$) of United Kingdom in 1966 to that in 1967?
Offer a very short reply. 1.04. What is the ratio of the Aid flow (current US$) of United States in 1966 to that in 1967?
Give a very brief answer. 1.25. What is the ratio of the Aid flow (current US$) in Iceland in 1966 to that in 1967?
Provide a succinct answer. 0.84. What is the ratio of the Aid flow (current US$) in European Union in 1966 to that in 1968?
Offer a terse response. 0.46. What is the ratio of the Aid flow (current US$) of United Kingdom in 1966 to that in 1968?
Provide a short and direct response. 1.03. What is the ratio of the Aid flow (current US$) in United States in 1966 to that in 1968?
Your answer should be very brief. 1.27. What is the ratio of the Aid flow (current US$) in Iceland in 1966 to that in 1968?
Offer a terse response. 0.44. What is the ratio of the Aid flow (current US$) in European Union in 1967 to that in 1968?
Your response must be concise. 0.88. What is the ratio of the Aid flow (current US$) of United Kingdom in 1967 to that in 1968?
Your answer should be very brief. 1. What is the ratio of the Aid flow (current US$) of United States in 1967 to that in 1968?
Offer a terse response. 1.02. What is the ratio of the Aid flow (current US$) of Iceland in 1967 to that in 1968?
Offer a very short reply. 0.52. What is the difference between the highest and the second highest Aid flow (current US$) of European Union?
Offer a very short reply. 4.41e+06. What is the difference between the highest and the second highest Aid flow (current US$) in United Kingdom?
Make the answer very short. 2.16e+06. What is the difference between the highest and the second highest Aid flow (current US$) of United States?
Provide a succinct answer. 1.09e+08. What is the difference between the highest and the second highest Aid flow (current US$) of Iceland?
Provide a short and direct response. 5.10e+05. What is the difference between the highest and the lowest Aid flow (current US$) of European Union?
Keep it short and to the point. 3.03e+07. What is the difference between the highest and the lowest Aid flow (current US$) in United Kingdom?
Provide a short and direct response. 1.68e+07. What is the difference between the highest and the lowest Aid flow (current US$) in United States?
Offer a terse response. 3.15e+08. What is the difference between the highest and the lowest Aid flow (current US$) of Iceland?
Keep it short and to the point. 1.26e+06. 